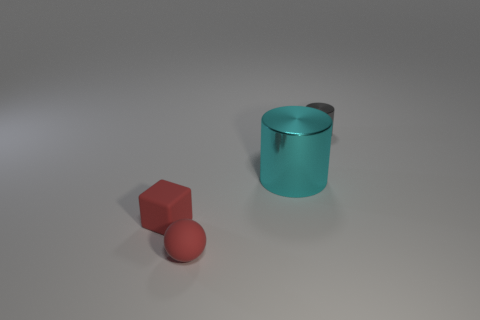There is a shiny cylinder that is in front of the small gray cylinder; how big is it?
Ensure brevity in your answer.  Large. There is another object that is the same shape as the big cyan object; what is it made of?
Keep it short and to the point. Metal. Is there any other thing that is the same size as the gray cylinder?
Ensure brevity in your answer.  Yes. What shape is the tiny rubber thing that is to the right of the tiny cube?
Offer a very short reply. Sphere. What number of cyan objects have the same shape as the gray object?
Provide a short and direct response. 1. Are there an equal number of gray shiny things that are behind the sphere and gray things that are to the left of the small gray shiny object?
Provide a short and direct response. No. Is there a object made of the same material as the red sphere?
Your answer should be very brief. Yes. Are the tiny red block and the tiny gray object made of the same material?
Make the answer very short. No. How many green objects are shiny cylinders or small shiny cylinders?
Provide a short and direct response. 0. Are there more small gray things in front of the large cyan cylinder than cylinders?
Your answer should be compact. No. 